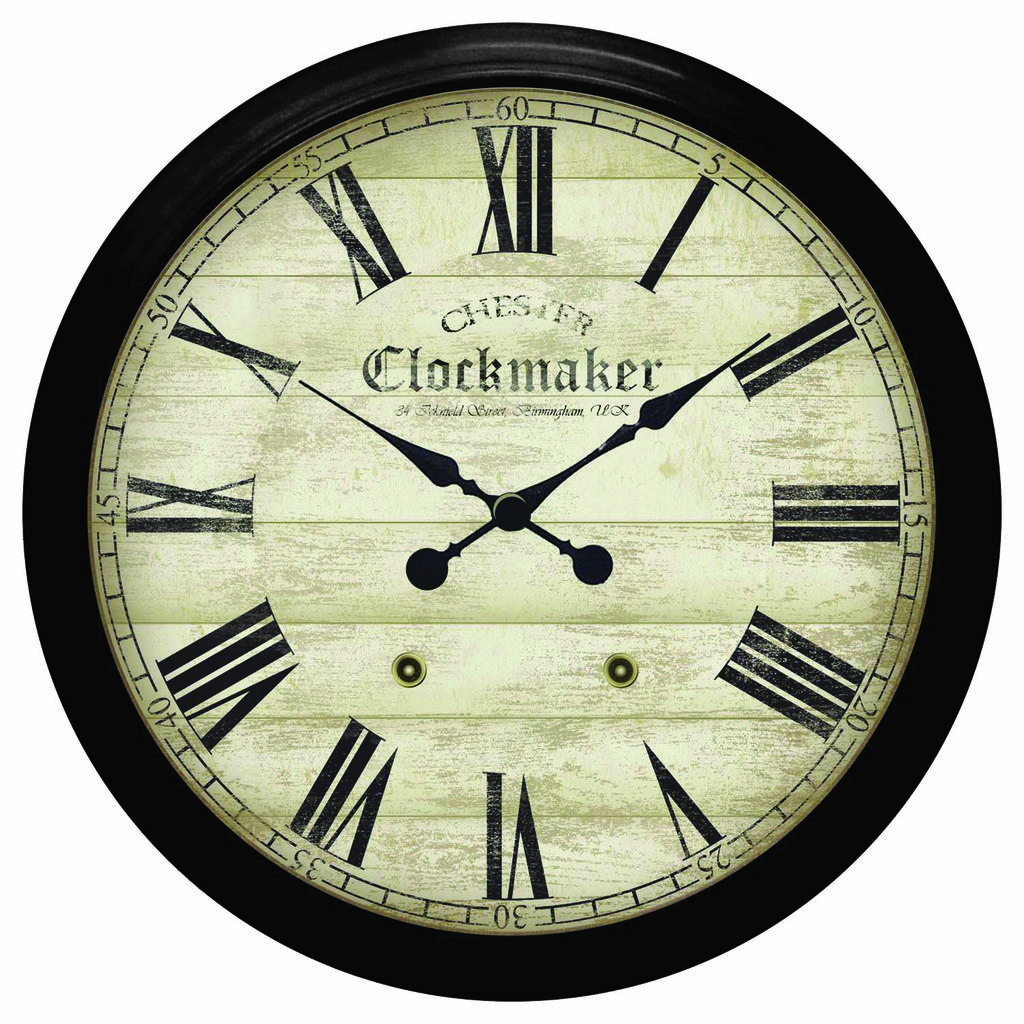What time does the clock show?
Provide a short and direct response. 10:09. What does the text on the clock say?
Provide a short and direct response. Chester clockmaker. 